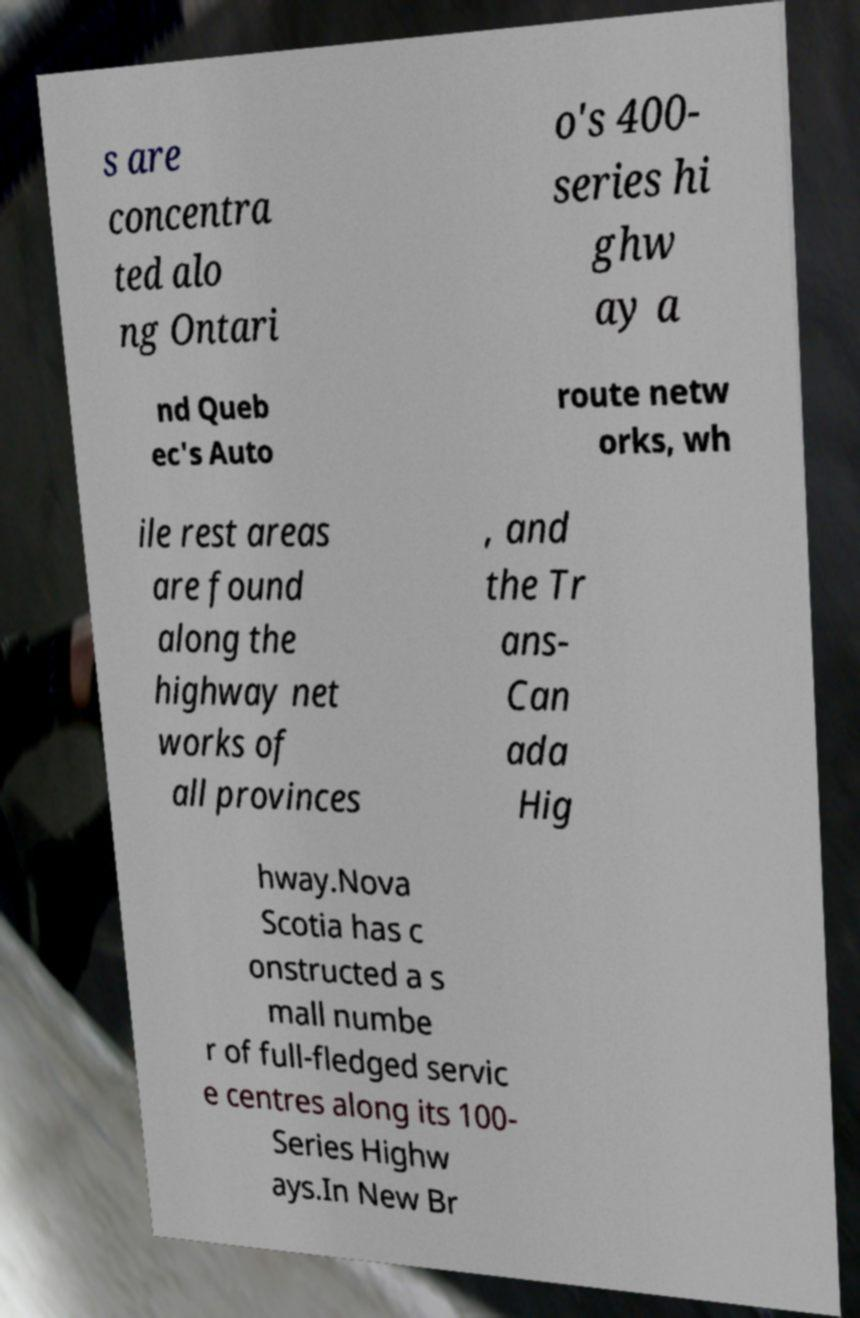For documentation purposes, I need the text within this image transcribed. Could you provide that? s are concentra ted alo ng Ontari o's 400- series hi ghw ay a nd Queb ec's Auto route netw orks, wh ile rest areas are found along the highway net works of all provinces , and the Tr ans- Can ada Hig hway.Nova Scotia has c onstructed a s mall numbe r of full-fledged servic e centres along its 100- Series Highw ays.In New Br 